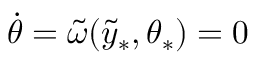Convert formula to latex. <formula><loc_0><loc_0><loc_500><loc_500>\dot { \theta } = \tilde { \omega } ( \tilde { y } _ { \ast } , \theta _ { \ast } ) = 0</formula> 